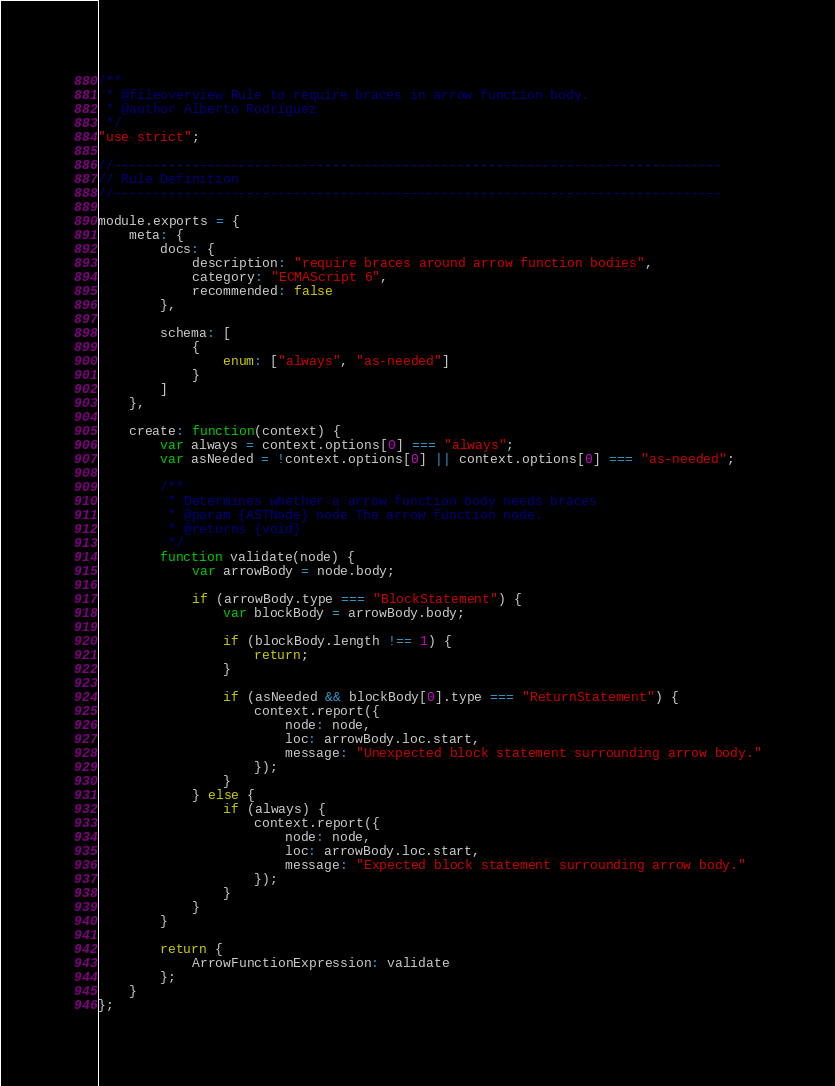Convert code to text. <code><loc_0><loc_0><loc_500><loc_500><_JavaScript_>/**
 * @fileoverview Rule to require braces in arrow function body.
 * @author Alberto Rodríguez
 */
"use strict";

//------------------------------------------------------------------------------
// Rule Definition
//------------------------------------------------------------------------------

module.exports = {
    meta: {
        docs: {
            description: "require braces around arrow function bodies",
            category: "ECMAScript 6",
            recommended: false
        },

        schema: [
            {
                enum: ["always", "as-needed"]
            }
        ]
    },

    create: function(context) {
        var always = context.options[0] === "always";
        var asNeeded = !context.options[0] || context.options[0] === "as-needed";

        /**
         * Determines whether a arrow function body needs braces
         * @param {ASTNode} node The arrow function node.
         * @returns {void}
         */
        function validate(node) {
            var arrowBody = node.body;

            if (arrowBody.type === "BlockStatement") {
                var blockBody = arrowBody.body;

                if (blockBody.length !== 1) {
                    return;
                }

                if (asNeeded && blockBody[0].type === "ReturnStatement") {
                    context.report({
                        node: node,
                        loc: arrowBody.loc.start,
                        message: "Unexpected block statement surrounding arrow body."
                    });
                }
            } else {
                if (always) {
                    context.report({
                        node: node,
                        loc: arrowBody.loc.start,
                        message: "Expected block statement surrounding arrow body."
                    });
                }
            }
        }

        return {
            ArrowFunctionExpression: validate
        };
    }
};
</code> 